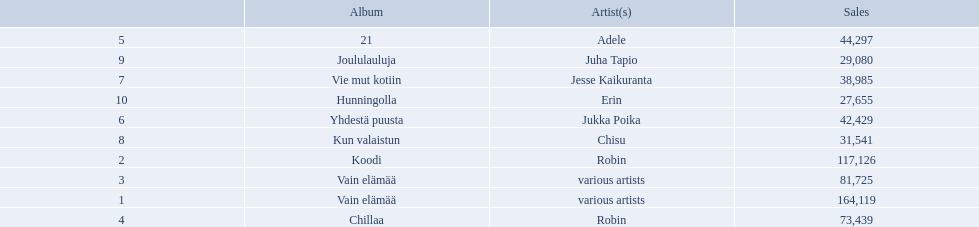Which artists' albums reached number one in finland during 2012? 164,119, 117,126, 81,725, 73,439, 44,297, 42,429, 38,985, 31,541, 29,080, 27,655. Can you parse all the data within this table? {'header': ['', 'Album', 'Artist(s)', 'Sales'], 'rows': [['5', '21', 'Adele', '44,297'], ['9', 'Joululauluja', 'Juha Tapio', '29,080'], ['7', 'Vie mut kotiin', 'Jesse Kaikuranta', '38,985'], ['10', 'Hunningolla', 'Erin', '27,655'], ['6', 'Yhdestä puusta', 'Jukka Poika', '42,429'], ['8', 'Kun valaistun', 'Chisu', '31,541'], ['2', 'Koodi', 'Robin', '117,126'], ['3', 'Vain elämää', 'various artists', '81,725'], ['1', 'Vain elämää', 'various artists', '164,119'], ['4', 'Chillaa', 'Robin', '73,439']]} What were the sales figures of these albums? Various artists, robin, various artists, robin, adele, jukka poika, jesse kaikuranta, chisu, juha tapio, erin. And did adele or chisu have more sales during this period? Adele. Who is the artist for 21 album? Adele. Who is the artist for kun valaistun? Chisu. Which album had the same artist as chillaa? Koodi. 